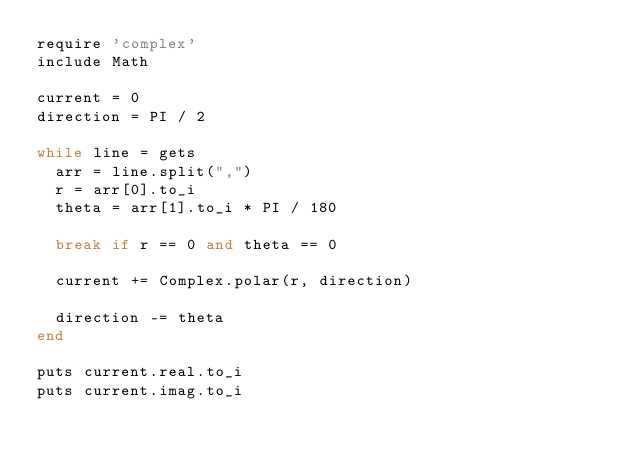Convert code to text. <code><loc_0><loc_0><loc_500><loc_500><_Ruby_>require 'complex'
include Math

current = 0
direction = PI / 2

while line = gets
  arr = line.split(",")
  r = arr[0].to_i
  theta = arr[1].to_i * PI / 180

  break if r == 0 and theta == 0
  
  current += Complex.polar(r, direction)

  direction -= theta
end

puts current.real.to_i
puts current.imag.to_i</code> 